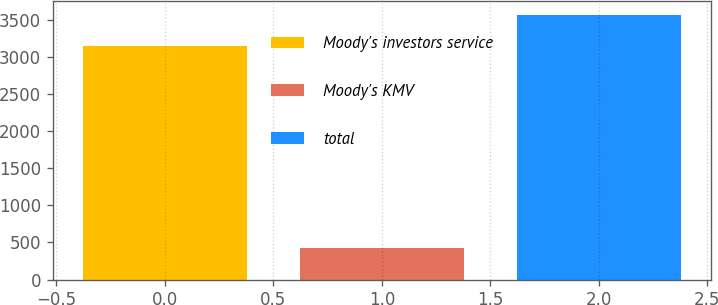Convert chart. <chart><loc_0><loc_0><loc_500><loc_500><bar_chart><fcel>Moody's investors service<fcel>Moody's KMV<fcel>total<nl><fcel>3153<fcel>419<fcel>3572<nl></chart> 